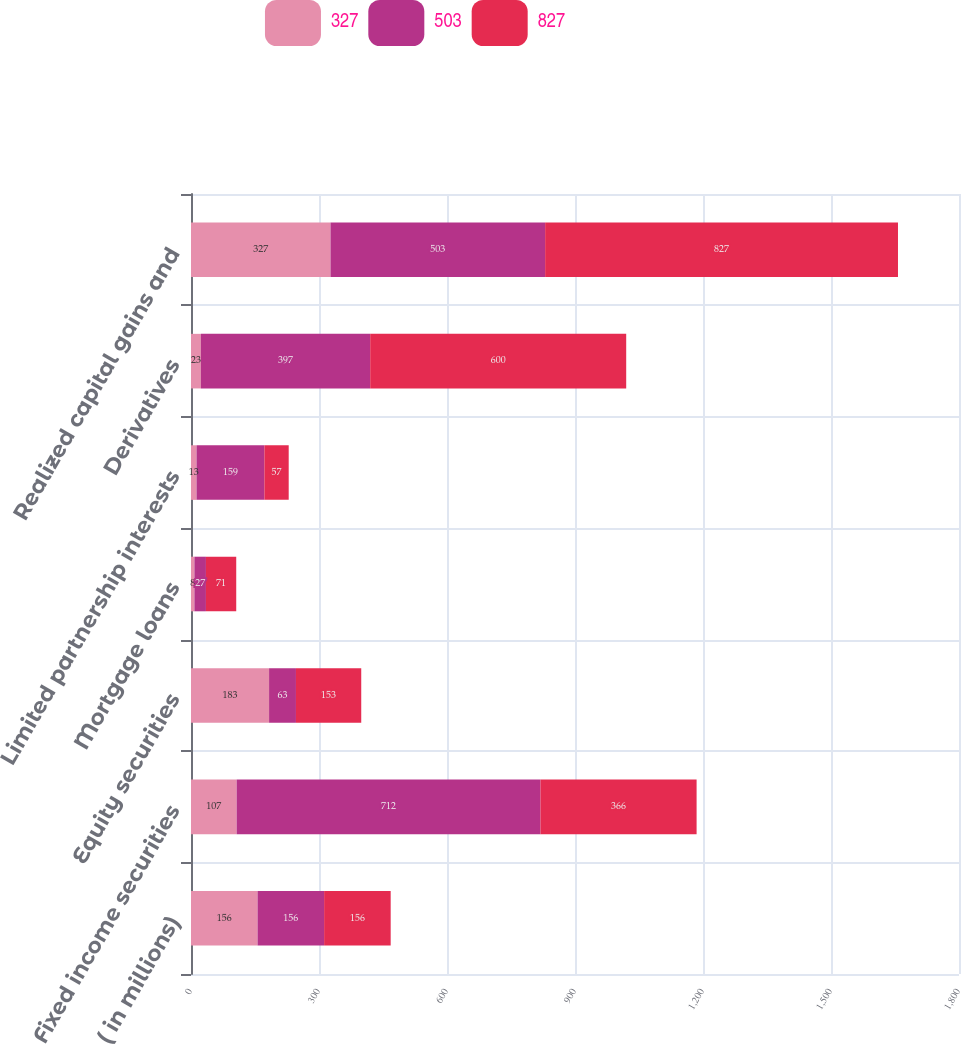Convert chart to OTSL. <chart><loc_0><loc_0><loc_500><loc_500><stacked_bar_chart><ecel><fcel>( in millions)<fcel>Fixed income securities<fcel>Equity securities<fcel>Mortgage loans<fcel>Limited partnership interests<fcel>Derivatives<fcel>Realized capital gains and<nl><fcel>327<fcel>156<fcel>107<fcel>183<fcel>8<fcel>13<fcel>23<fcel>327<nl><fcel>503<fcel>156<fcel>712<fcel>63<fcel>27<fcel>159<fcel>397<fcel>503<nl><fcel>827<fcel>156<fcel>366<fcel>153<fcel>71<fcel>57<fcel>600<fcel>827<nl></chart> 